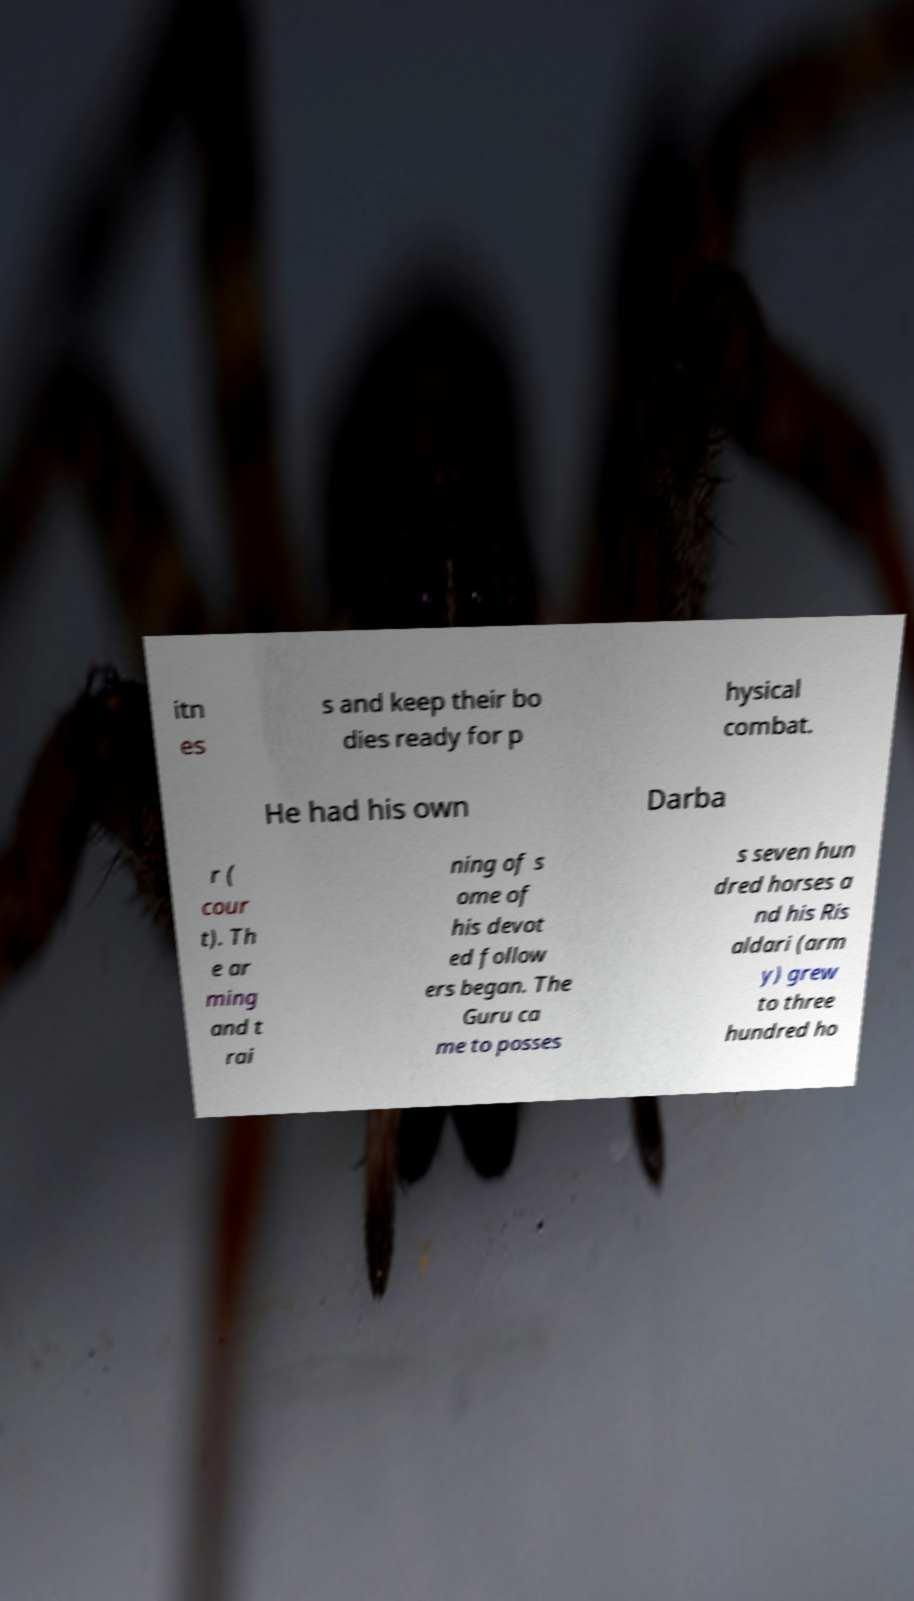There's text embedded in this image that I need extracted. Can you transcribe it verbatim? itn es s and keep their bo dies ready for p hysical combat. He had his own Darba r ( cour t). Th e ar ming and t rai ning of s ome of his devot ed follow ers began. The Guru ca me to posses s seven hun dred horses a nd his Ris aldari (arm y) grew to three hundred ho 